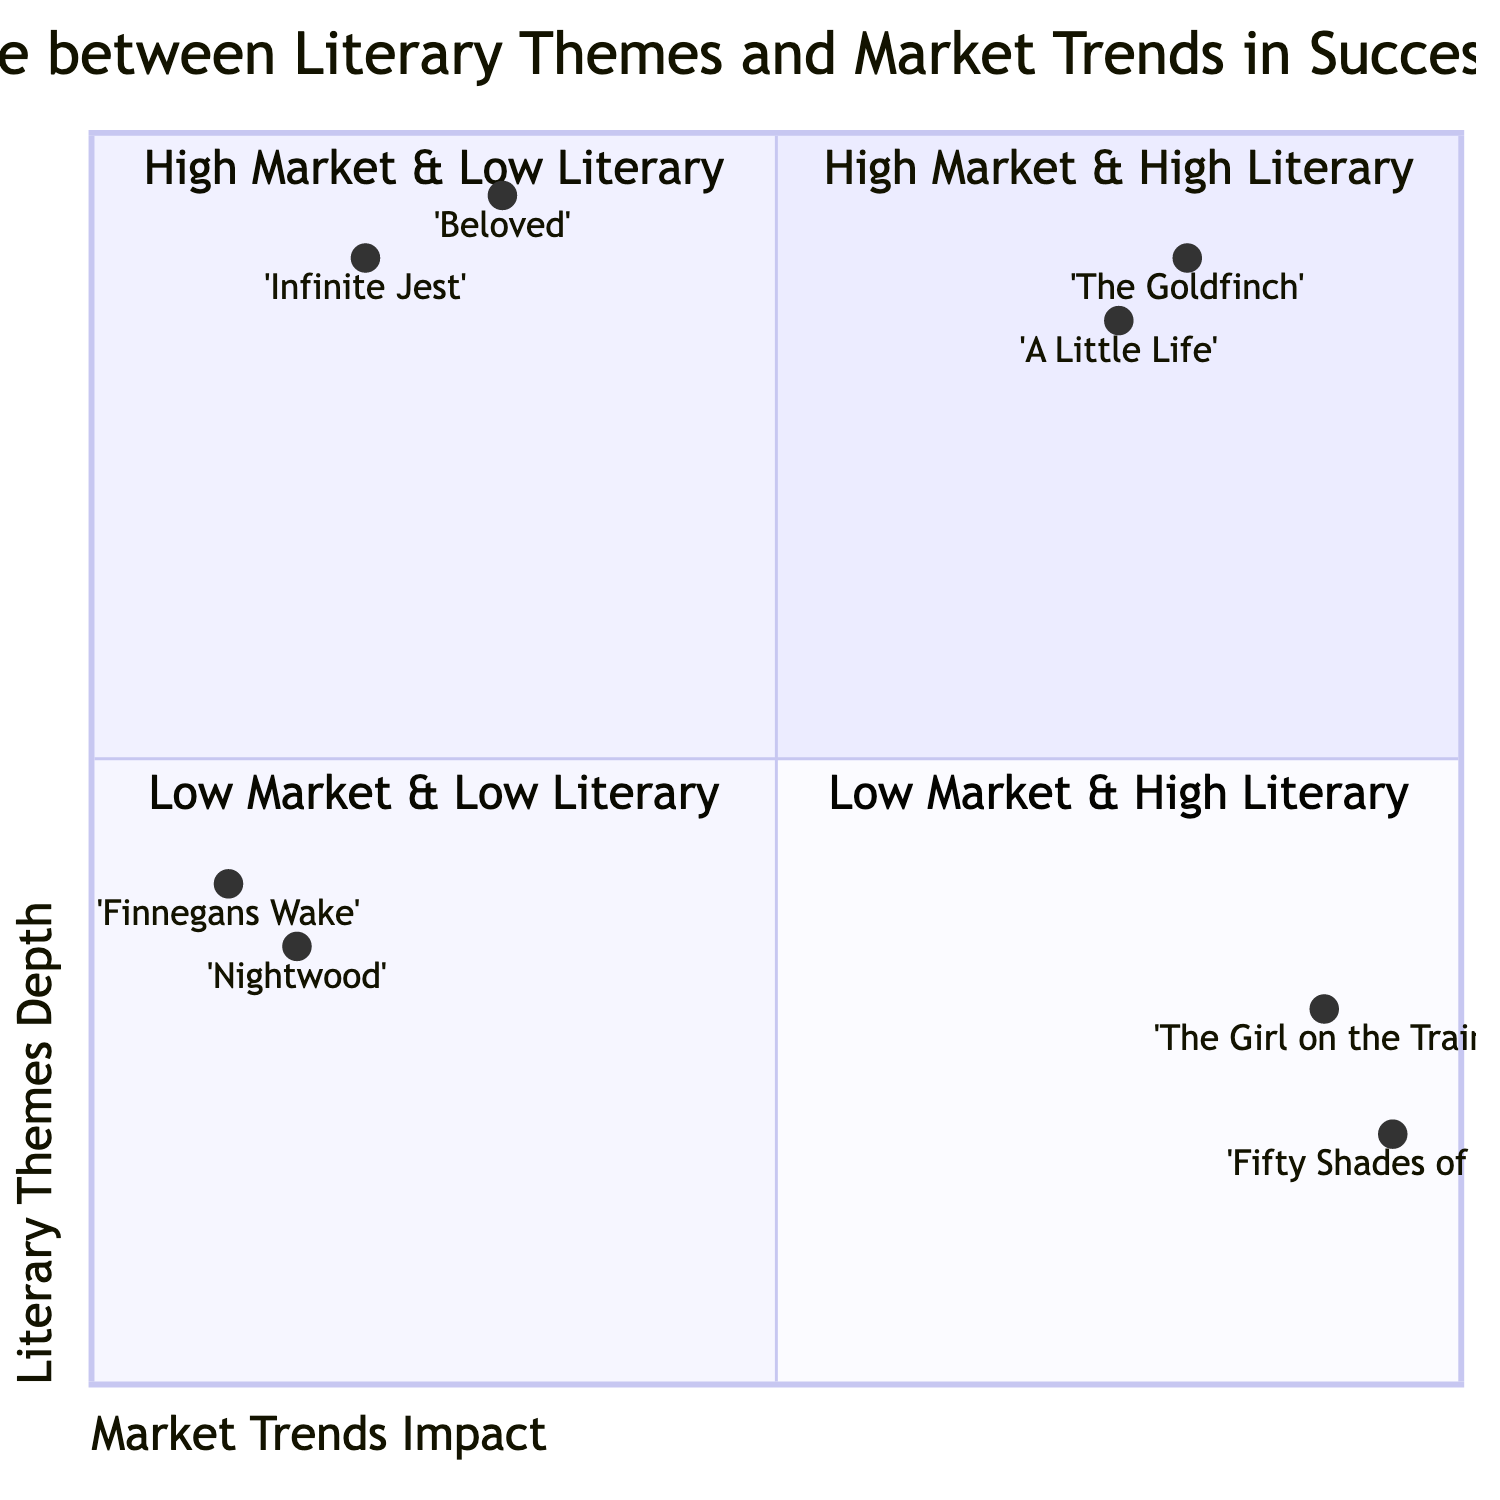What are the two examples in the High Market & High Literary quadrant? The High Market & High Literary quadrant contains two novels: 'The Goldfinch' by Donna Tartt and 'A Little Life' by Hanya Yanagihara.
Answer: 'The Goldfinch', 'A Little Life' Which quadrant has novels with profound literary themes but lower market alignment? This is the Low Market & High Literary quadrant, where novels possess deep literary themes but do not align well with current market trends.
Answer: Low Market & High Literary How many novels are in the High Market & Low Literary quadrant? There are two novels in this quadrant: 'The Girl on the Train' and 'Fifty Shades of Grey'.
Answer: 2 What is the market trends impact value of 'Infinite Jest'? 'Infinite Jest' has a market trends impact value of 0.2.
Answer: 0.2 Which novel has the highest literary themes depth in the Low Market & Low Literary quadrant? 'Finnegans Wake' is in the Low Market & Low Literary quadrant and has the highest literary themes depth value of 0.4 among the novels in this quadrant.
Answer: 0.4 Which quadrant contains the novel with the lowest literary themes depth? The High Market & Low Literary quadrant contains 'Fifty Shades of Grey', which has the lowest literary themes depth of 0.2.
Answer: High Market & Low Literary What are the coordinates of 'The Girl on the Train'? The coordinates of 'The Girl on the Train' are [0.9, 0.3].
Answer: [0.9, 0.3] Which quadrant has novels that are both highly marketable and literarily rich? The High Market & High Literary quadrant includes novels that are both highly marketable and have depth in literary themes.
Answer: High Market & High Literary 